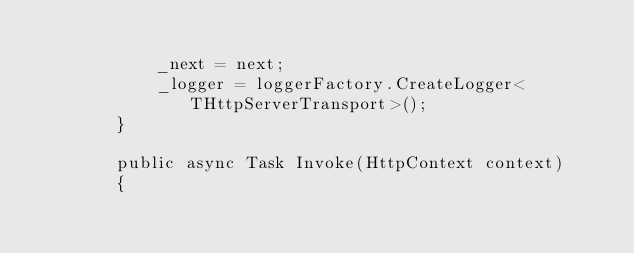<code> <loc_0><loc_0><loc_500><loc_500><_C#_>
            _next = next;
            _logger = loggerFactory.CreateLogger<THttpServerTransport>();
        }

        public async Task Invoke(HttpContext context)
        {</code> 